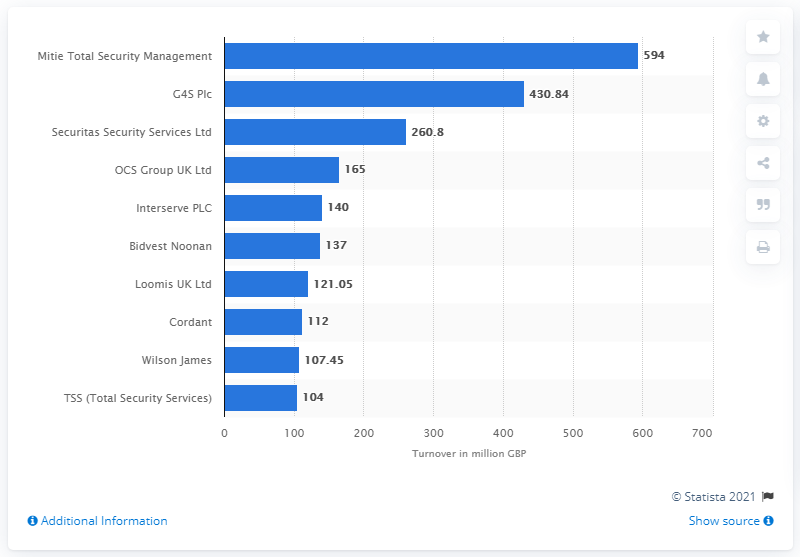Mention a couple of crucial points in this snapshot. The turnover of G4S in the UK in 2019 was 430.84. 